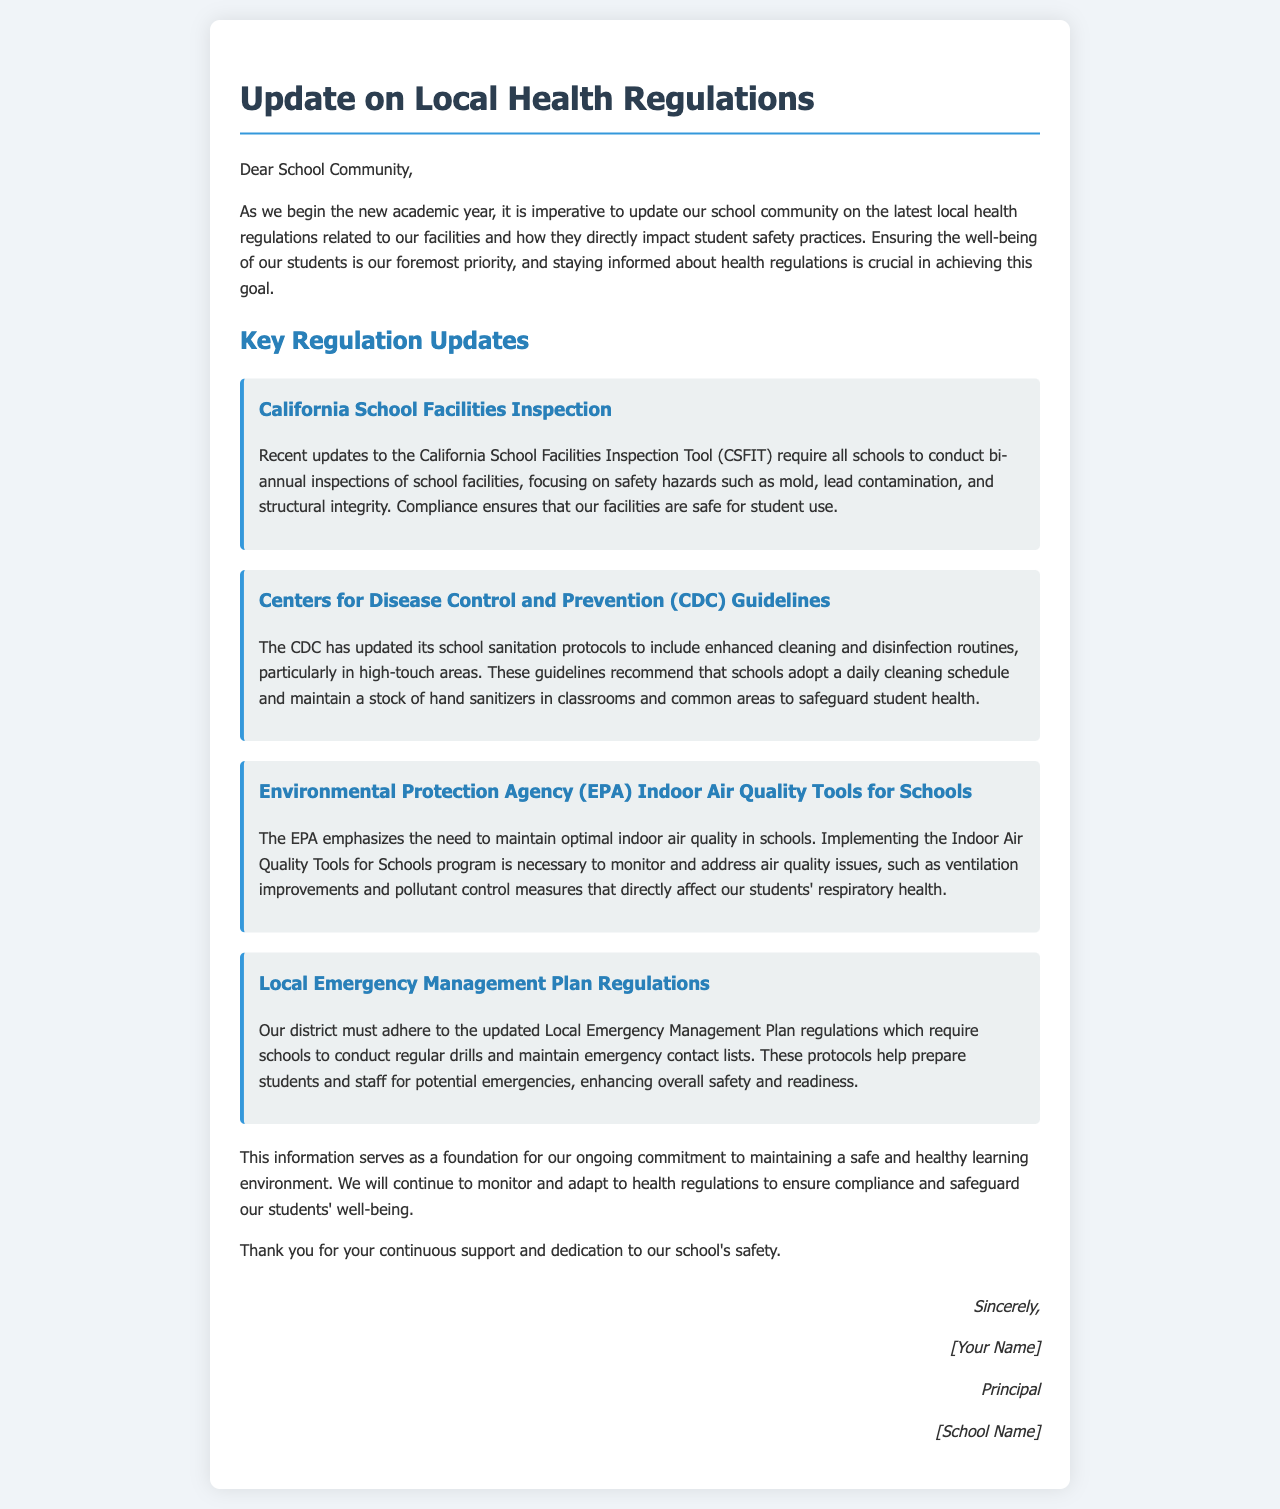What is the primary purpose of the letter? The letter's primary purpose is to update the school community on local health regulations affecting student safety practices.
Answer: Update on local health regulations How often must schools conduct inspections according to CSFIT? CSFIT requires schools to conduct bi-annual inspections to ensure safety.
Answer: Bi-annual What specific areas does the CDC recommend for enhanced cleaning? The CDC recommends enhanced cleaning and disinfection in high-touch areas.
Answer: High-touch areas Which agency's guidelines focus on indoor air quality? The EPA's guidelines focus on maintaining optimal indoor air quality in schools.
Answer: EPA What requirement is included in the Local Emergency Management Plan regulations? Regular drills and maintaining emergency contact lists are required by the regulations.
Answer: Regular drills What is the overall commitment expressed in the letter? The overall commitment expressed is to maintain a safe and healthy learning environment for students.
Answer: Safe and healthy learning environment Who is the author of the letter? The author of the letter is the school principal.
Answer: Principal What agencies are cited in the letter related to health regulations? The letter cites California School Facilities Inspection, CDC, and EPA related to health regulations.
Answer: California, CDC, EPA 